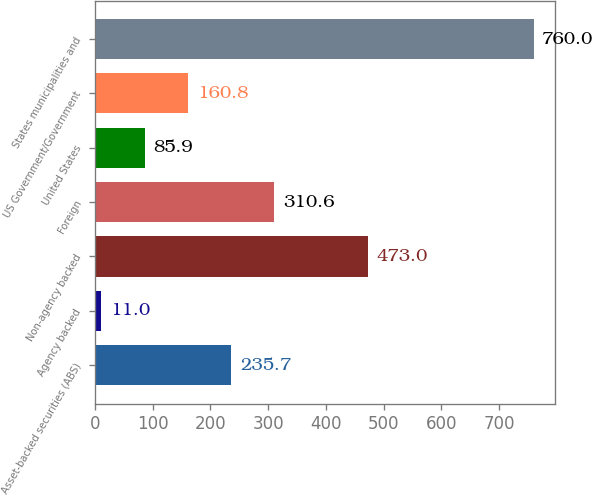<chart> <loc_0><loc_0><loc_500><loc_500><bar_chart><fcel>Asset-backed securities (ABS)<fcel>Agency backed<fcel>Non-agency backed<fcel>Foreign<fcel>United States<fcel>US Government/Government<fcel>States municipalities and<nl><fcel>235.7<fcel>11<fcel>473<fcel>310.6<fcel>85.9<fcel>160.8<fcel>760<nl></chart> 